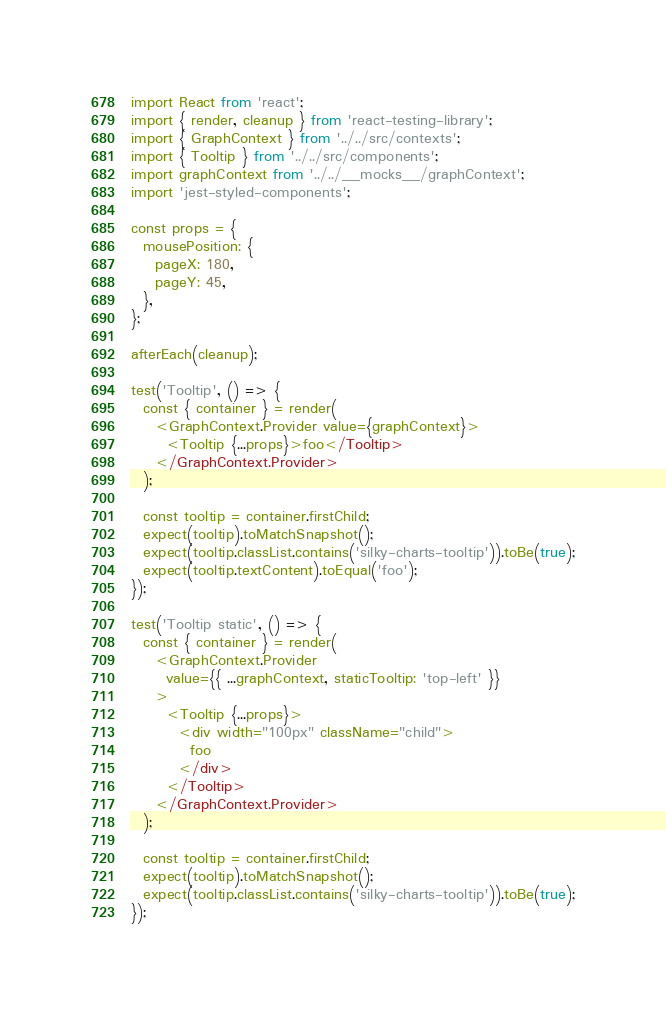Convert code to text. <code><loc_0><loc_0><loc_500><loc_500><_JavaScript_>import React from 'react';
import { render, cleanup } from 'react-testing-library';
import { GraphContext } from '../../src/contexts';
import { Tooltip } from '../../src/components';
import graphContext from '../../__mocks__/graphContext';
import 'jest-styled-components';

const props = {
  mousePosition: {
    pageX: 180,
    pageY: 45,
  },
};

afterEach(cleanup);

test('Tooltip', () => {
  const { container } = render(
    <GraphContext.Provider value={graphContext}>
      <Tooltip {...props}>foo</Tooltip>
    </GraphContext.Provider>
  );

  const tooltip = container.firstChild;
  expect(tooltip).toMatchSnapshot();
  expect(tooltip.classList.contains('silky-charts-tooltip')).toBe(true);
  expect(tooltip.textContent).toEqual('foo');
});

test('Tooltip static', () => {
  const { container } = render(
    <GraphContext.Provider
      value={{ ...graphContext, staticTooltip: 'top-left' }}
    >
      <Tooltip {...props}>
        <div width="100px" className="child">
          foo
        </div>
      </Tooltip>
    </GraphContext.Provider>
  );

  const tooltip = container.firstChild;
  expect(tooltip).toMatchSnapshot();
  expect(tooltip.classList.contains('silky-charts-tooltip')).toBe(true);
});
</code> 